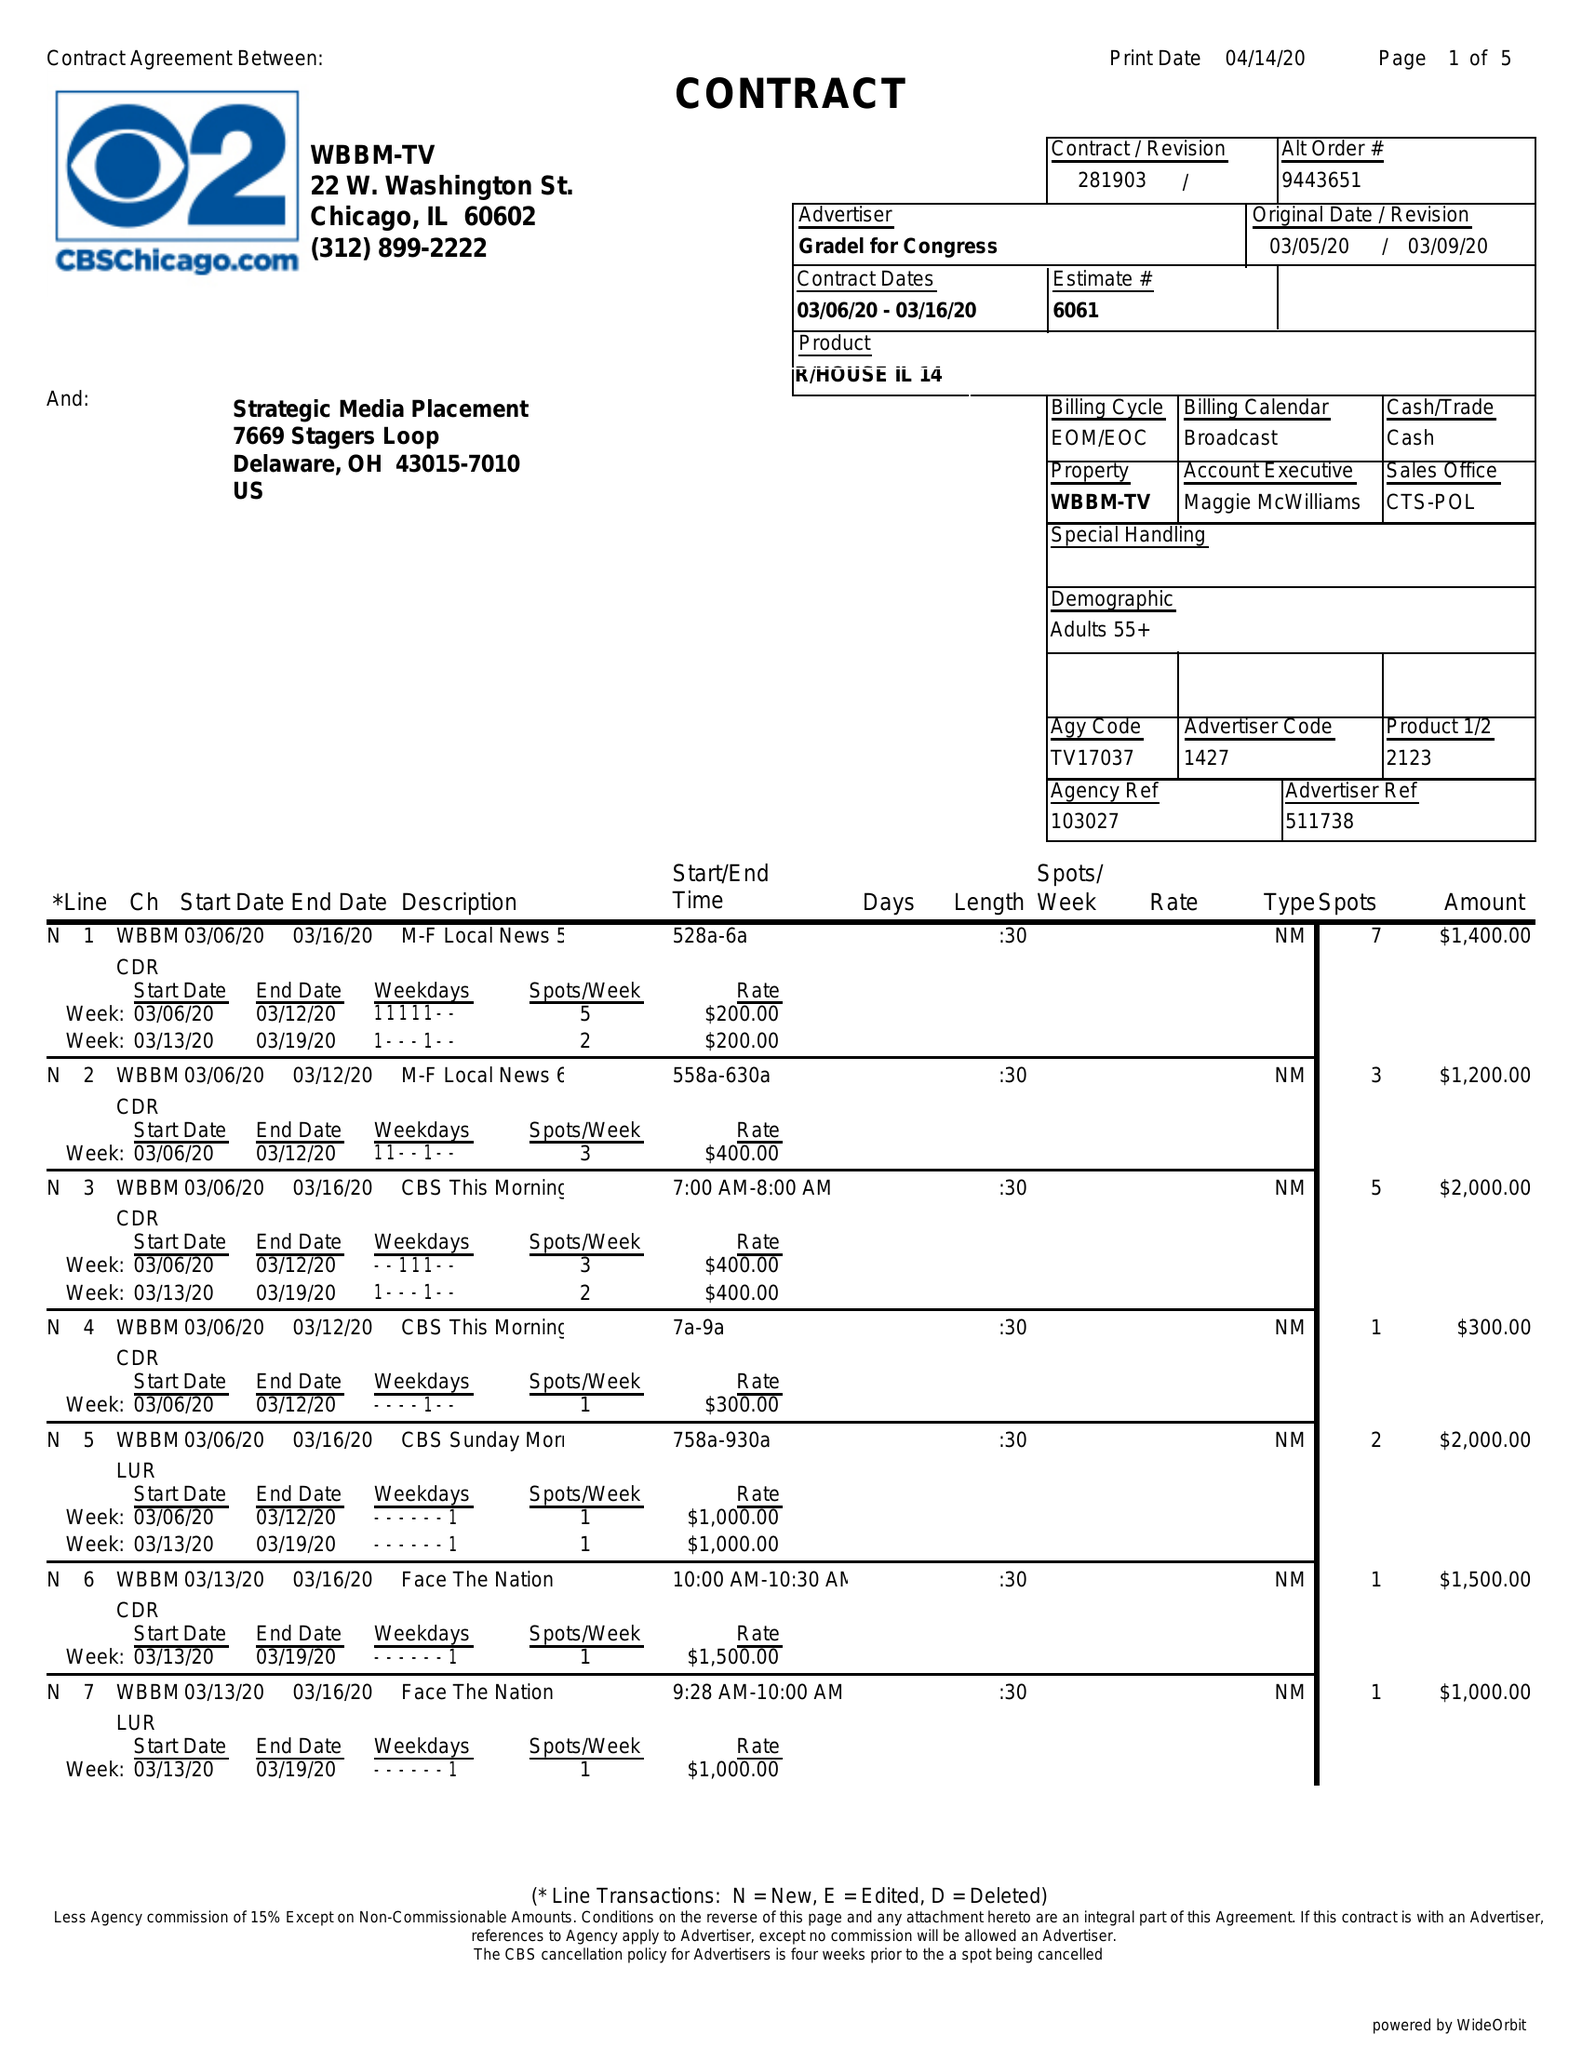What is the value for the gross_amount?
Answer the question using a single word or phrase. 75100.00 